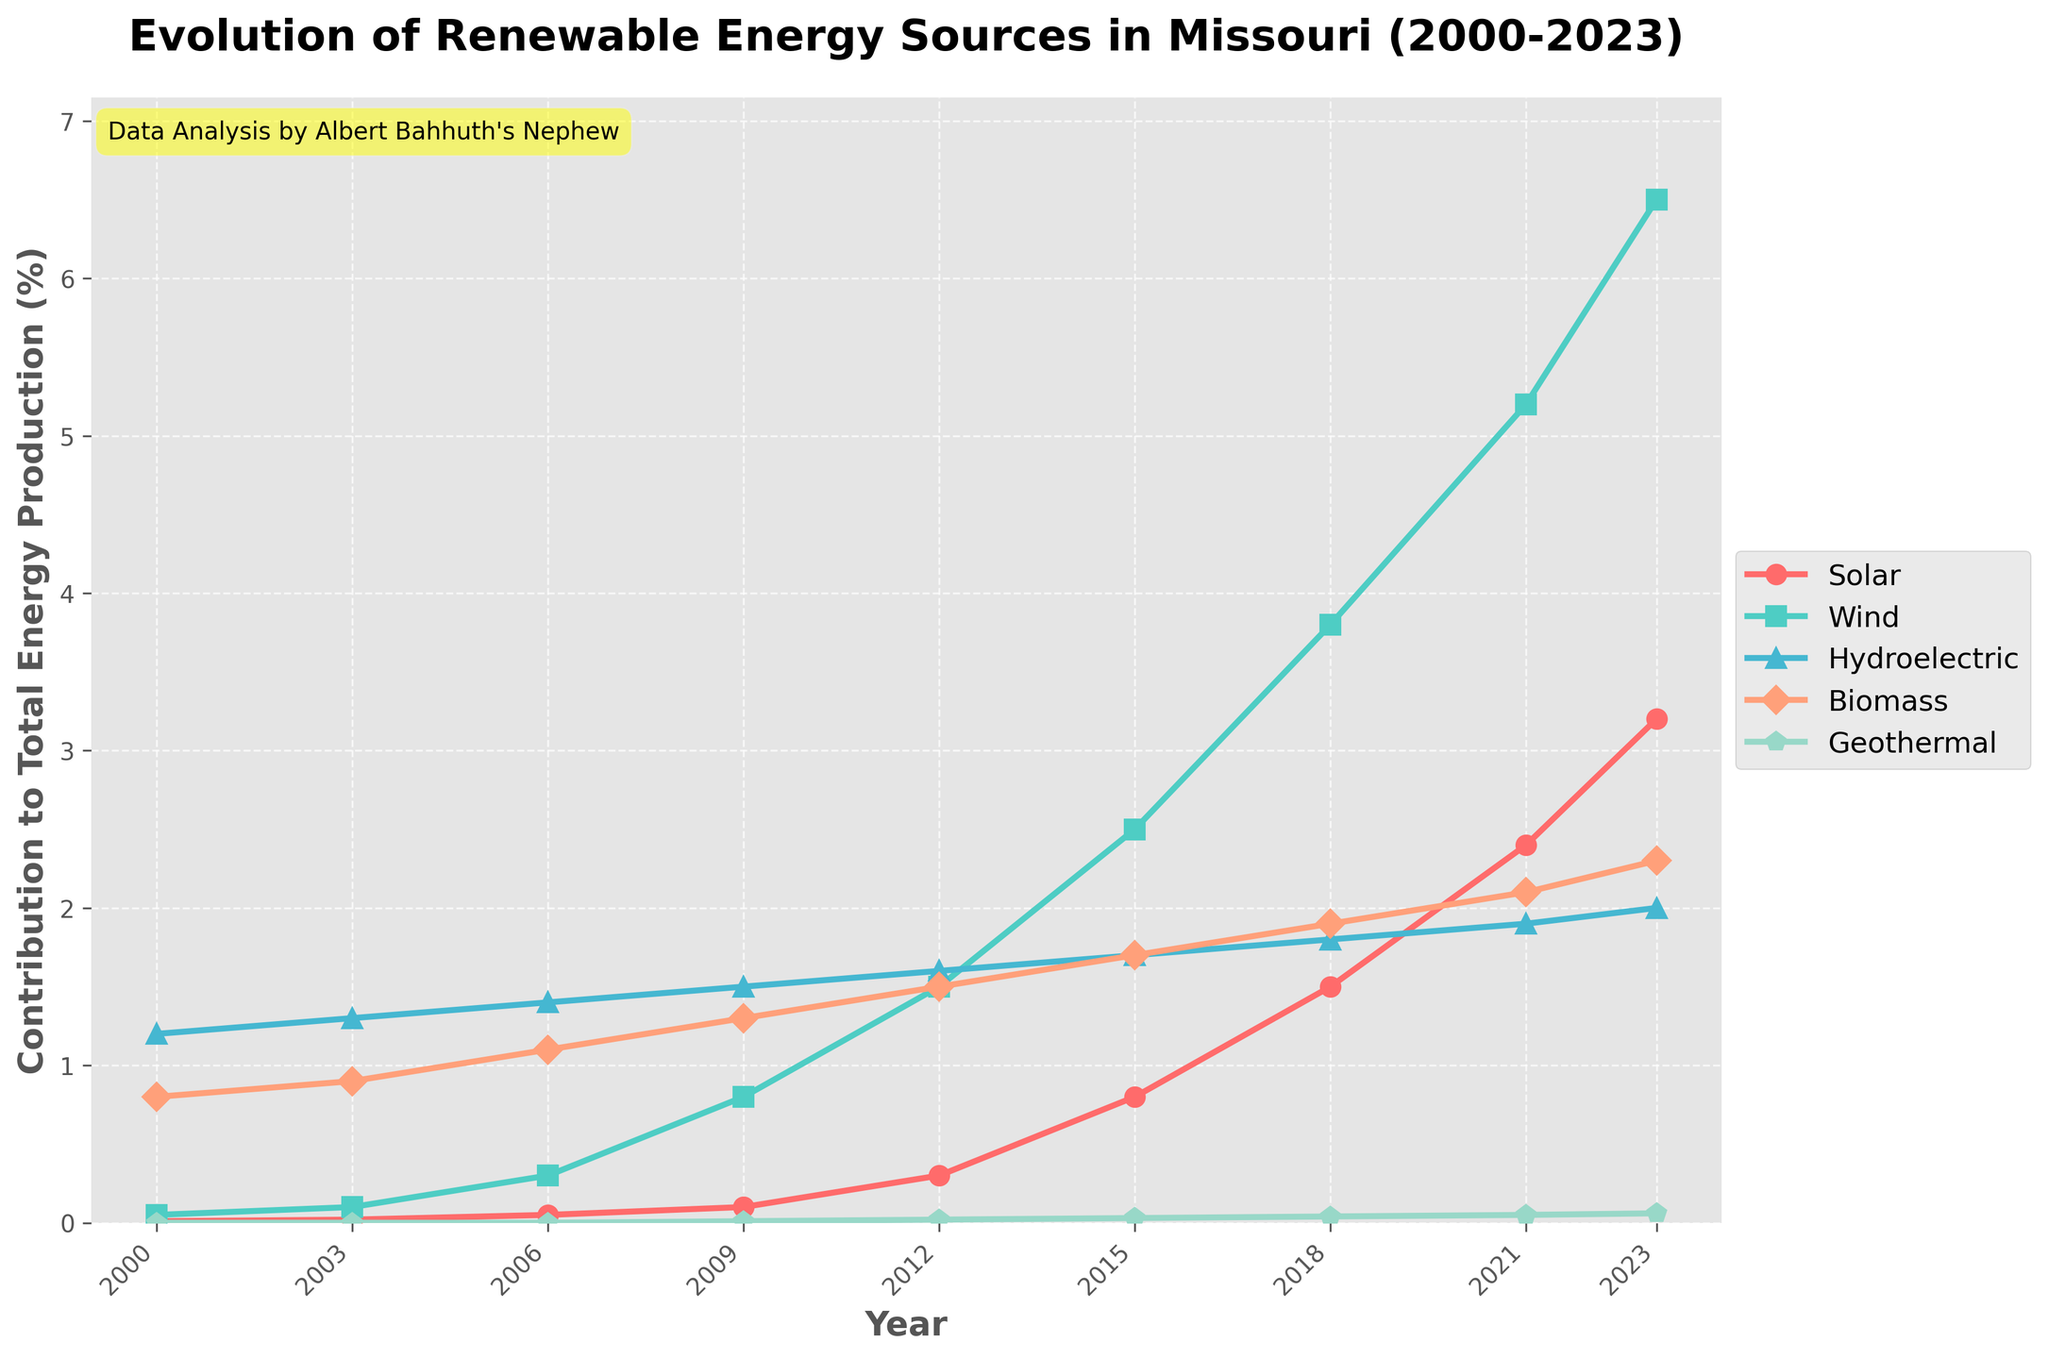What's the average contribution of solar energy to total energy production in 2023 and 2021 combined? To find the average contribution of solar energy in 2023 and 2021, sum the contributions of both years and divide by 2. The values are 3.2% for 2023 and 2.4% for 2021. So, (3.2 + 2.4) / 2 = 2.8
Answer: 2.8% Which renewable energy source had the highest growth in contribution from 2000 to 2023? To determine which energy source had the highest growth, subtract the 2000 contribution from the 2023 contribution for each energy source. The growths are: Solar (3.2 - 0.01), Wind (6.5 - 0.05), Hydroelectric (2.0 - 1.2), Biomass (2.3 - 0.8), Geothermal (0.06 - 0). Wind has the highest growth at 6.45%.
Answer: Wind In which year did wind energy’s contribution surpass 1% for the first time? Identify the year when wind energy's contribution exceeded 1% for the first time. Looking at the chart, this happened in 2012 when wind energy reached 1.5%.
Answer: 2012 Between 2018 and 2023, which energy source showed the least increase in contribution? Calculate the increase for each source from 2018 to 2023: Solar (3.2 - 1.5), Wind (6.5 - 3.8), Hydroelectric (2.0 - 1.8), Biomass (2.3 - 1.9), Geothermal (0.06 - 0.04). Hydroelectric shows the least increase (0.2).
Answer: Hydroelectric By how much did the contribution of biomass energy change from 2003 to 2018? To find the change, subtract the 2003 contribution value from the 2018 value. Biomass has values of 0.9% in 2003 and 1.9% in 2018. The change is 1.9 - 0.9 = 1.0.
Answer: 1.0 What is the trend of geothermal energy's contribution from 2000 to 2023? Geothermal energy's contribution started at 0 in 2000 and gradually increased to 0.06 by 2023, indicating a slow but steady rising trend.
Answer: Increasing How did the contributions of solar and wind energy compare in 2009? Look at the contributions for 2009: Solar (0.1%), Wind (0.8%). Wind energy’s contribution was much higher than solar.
Answer: Wind was higher What is the cumulative contribution of all renewable energy sources in 2023? Sum up the contributions of all renewable sources in 2023: Solar (3.2), Wind (6.5), Hydroelectric (2.0), Biomass (2.3), and Geothermal (0.06). The sum is 3.2 + 6.5 + 2.0 + 2.3 + 0.06 = 14.06.
Answer: 14.06% In 2000, which renewable energy source had the highest contribution? Looking at the contributions in 2000: Solar (0.01), Wind (0.05), Hydroelectric (1.2), Biomass (0.8), Geothermal (0). Hydroelectric had the highest contribution at 1.2%.
Answer: Hydroelectric Which energy source experienced a continuous increase in contribution in every recorded year from 2000 to 2023? Analyze the trend for each energy source in the chart. Solar shows a continuous increase in contribution in every year recorded (from 0.01 in 2000 to 3.2 in 2023).
Answer: Solar 